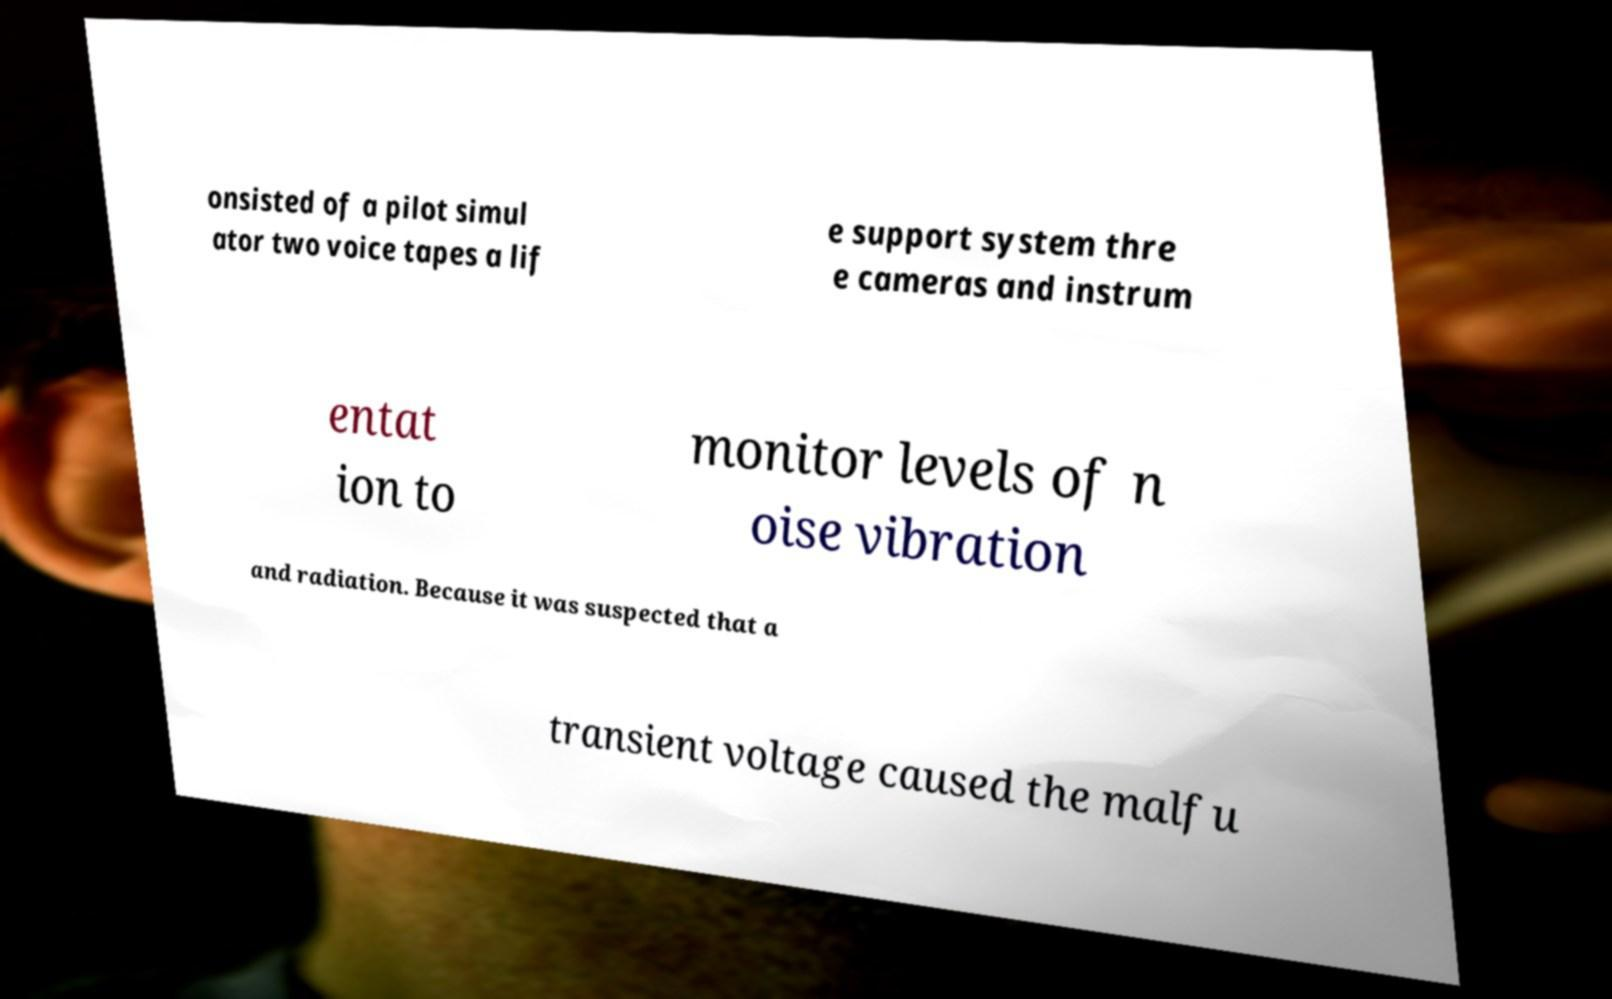What messages or text are displayed in this image? I need them in a readable, typed format. onsisted of a pilot simul ator two voice tapes a lif e support system thre e cameras and instrum entat ion to monitor levels of n oise vibration and radiation. Because it was suspected that a transient voltage caused the malfu 